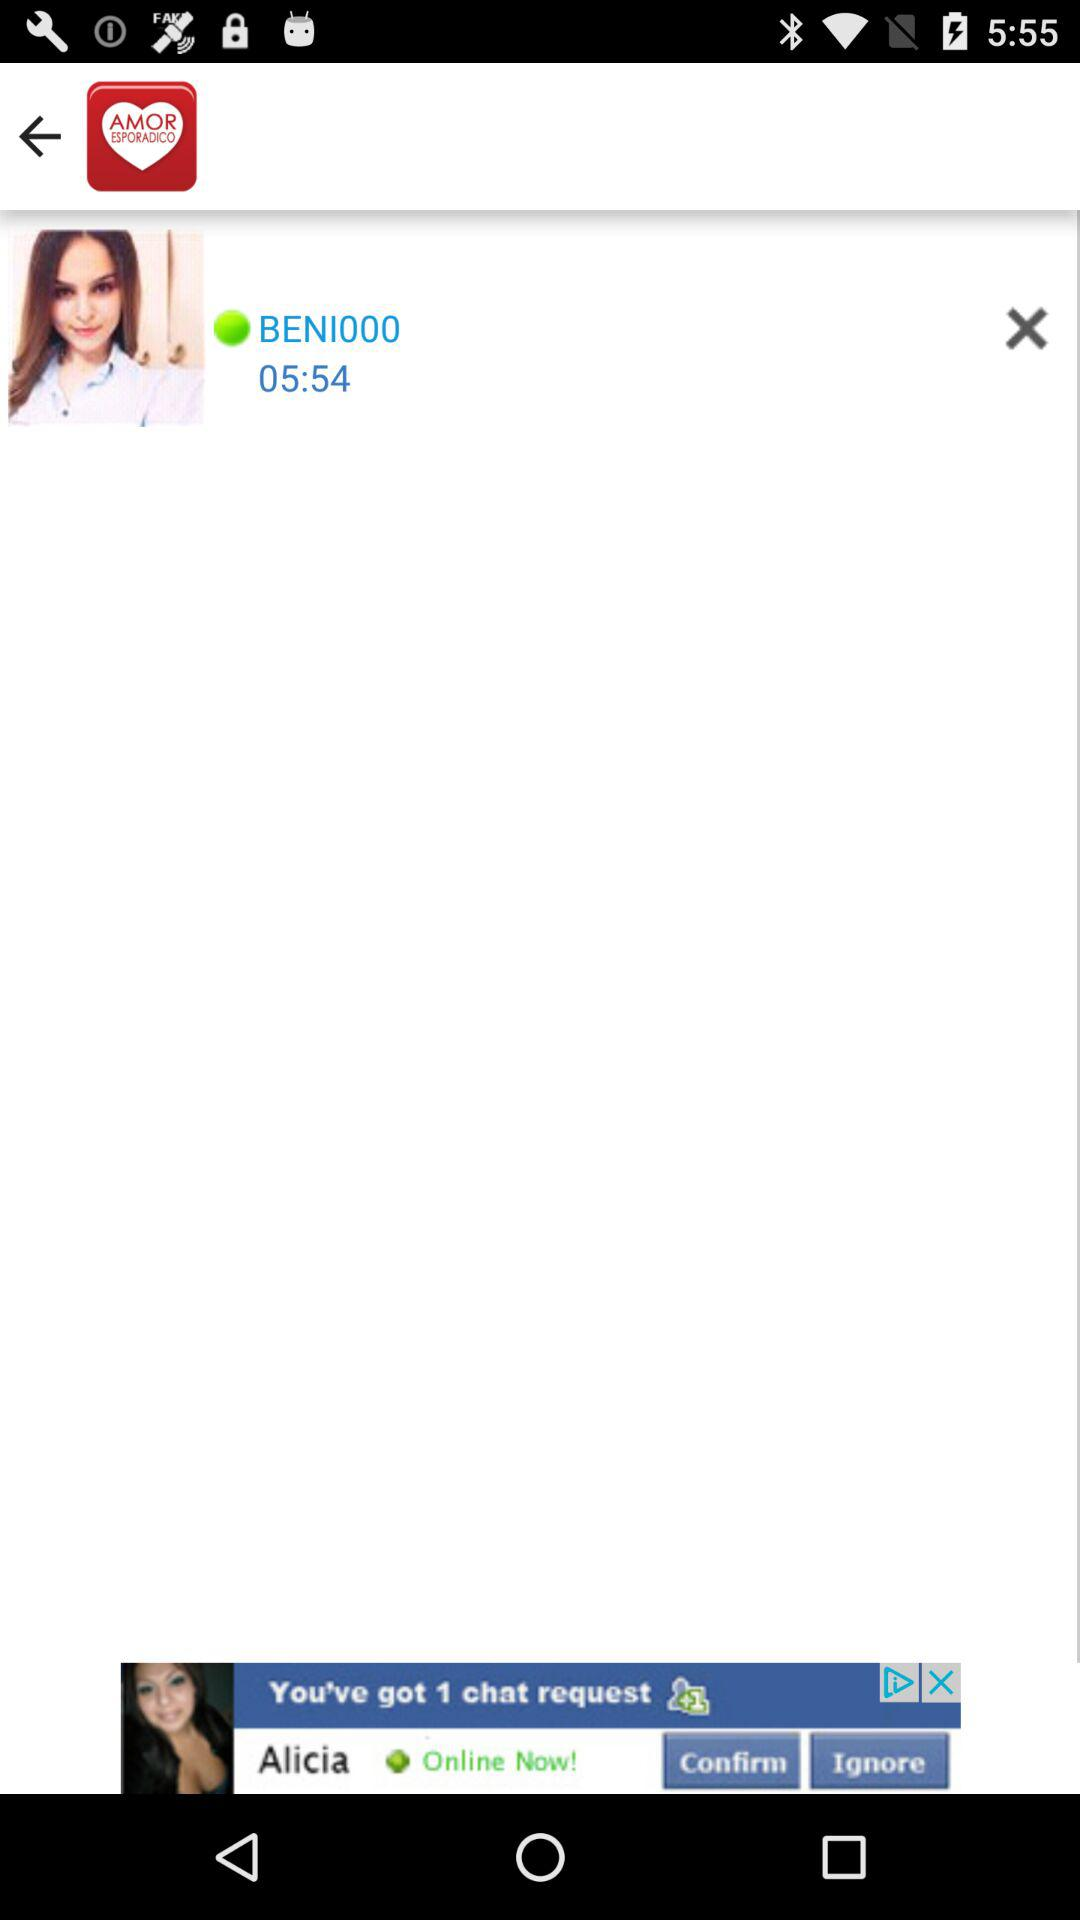What is the username? The username is "BENI000". 